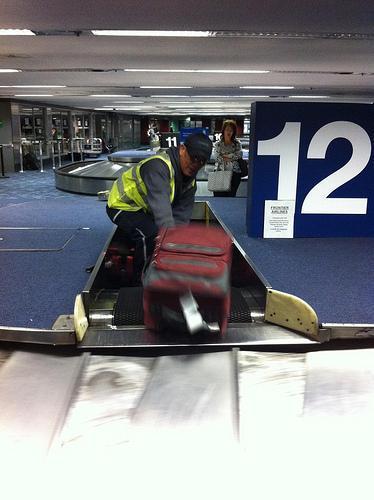How many pieces of luggage are there in the picture?
Give a very brief answer. 1. 